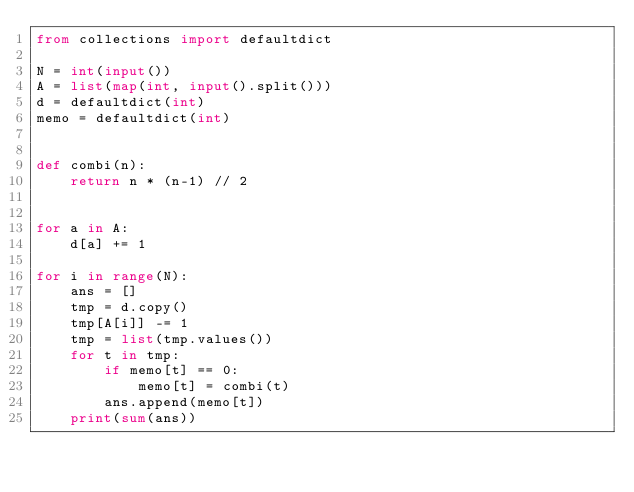<code> <loc_0><loc_0><loc_500><loc_500><_Python_>from collections import defaultdict

N = int(input())
A = list(map(int, input().split()))
d = defaultdict(int)
memo = defaultdict(int)


def combi(n):
    return n * (n-1) // 2


for a in A:
    d[a] += 1

for i in range(N):
    ans = []
    tmp = d.copy()
    tmp[A[i]] -= 1
    tmp = list(tmp.values())
    for t in tmp:
        if memo[t] == 0:
            memo[t] = combi(t)
        ans.append(memo[t])
    print(sum(ans))</code> 